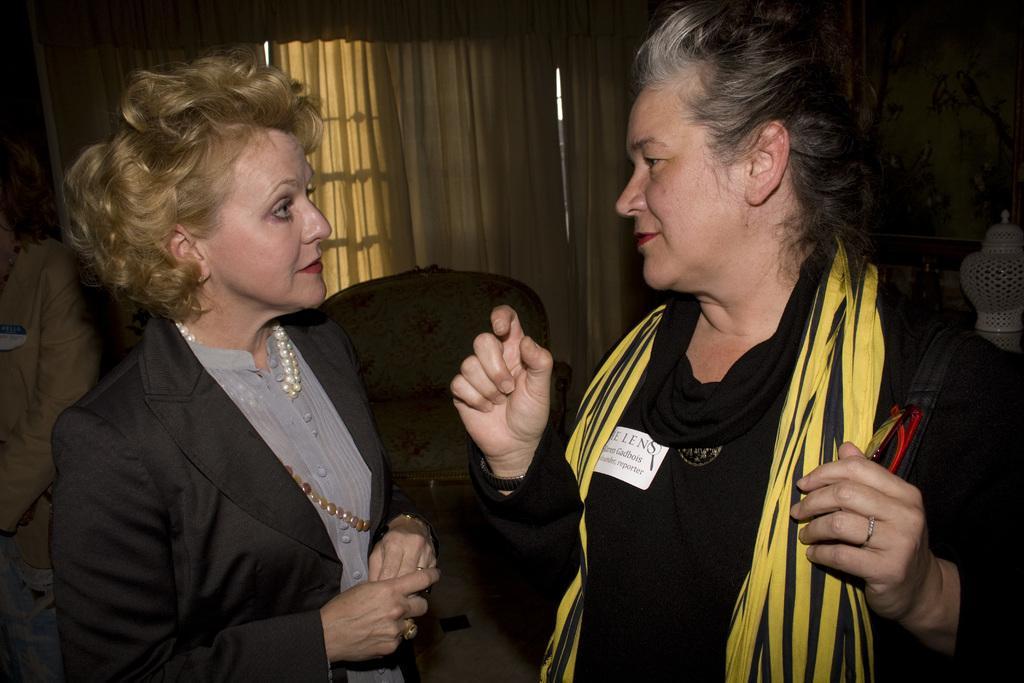Describe this image in one or two sentences. In this image we can see women, standing on the floor. In the background we can see chairs, person, window and curtain. 